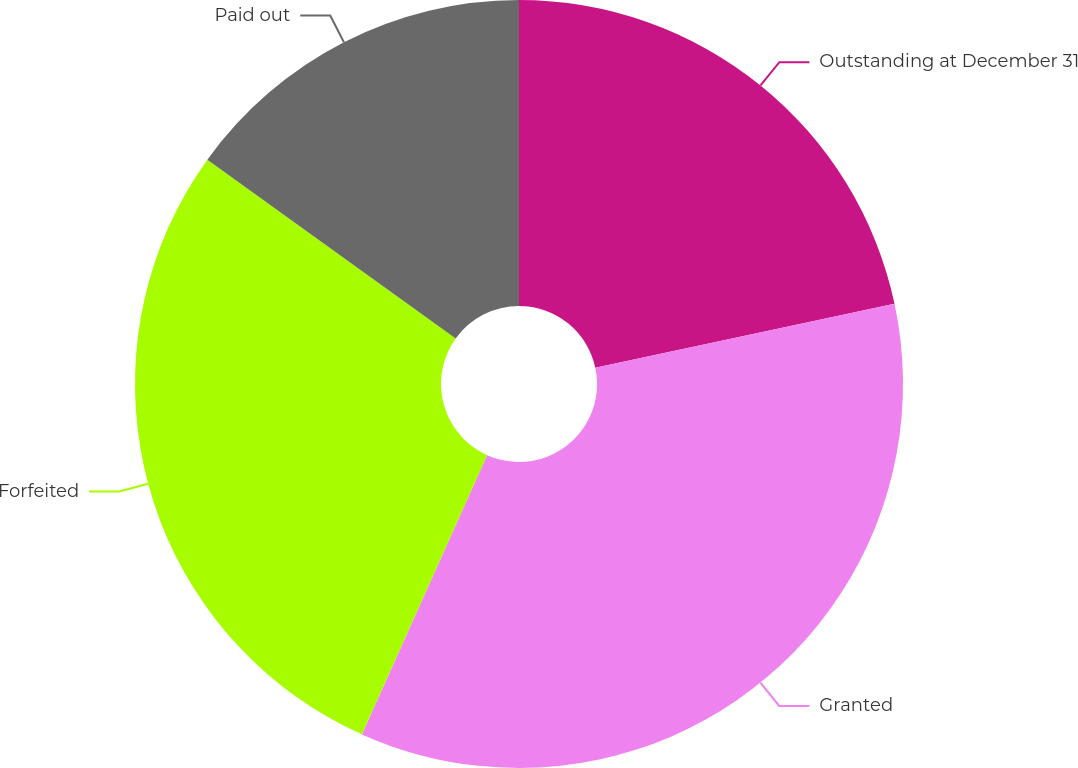Convert chart. <chart><loc_0><loc_0><loc_500><loc_500><pie_chart><fcel>Outstanding at December 31<fcel>Granted<fcel>Forfeited<fcel>Paid out<nl><fcel>21.65%<fcel>35.06%<fcel>28.22%<fcel>15.07%<nl></chart> 